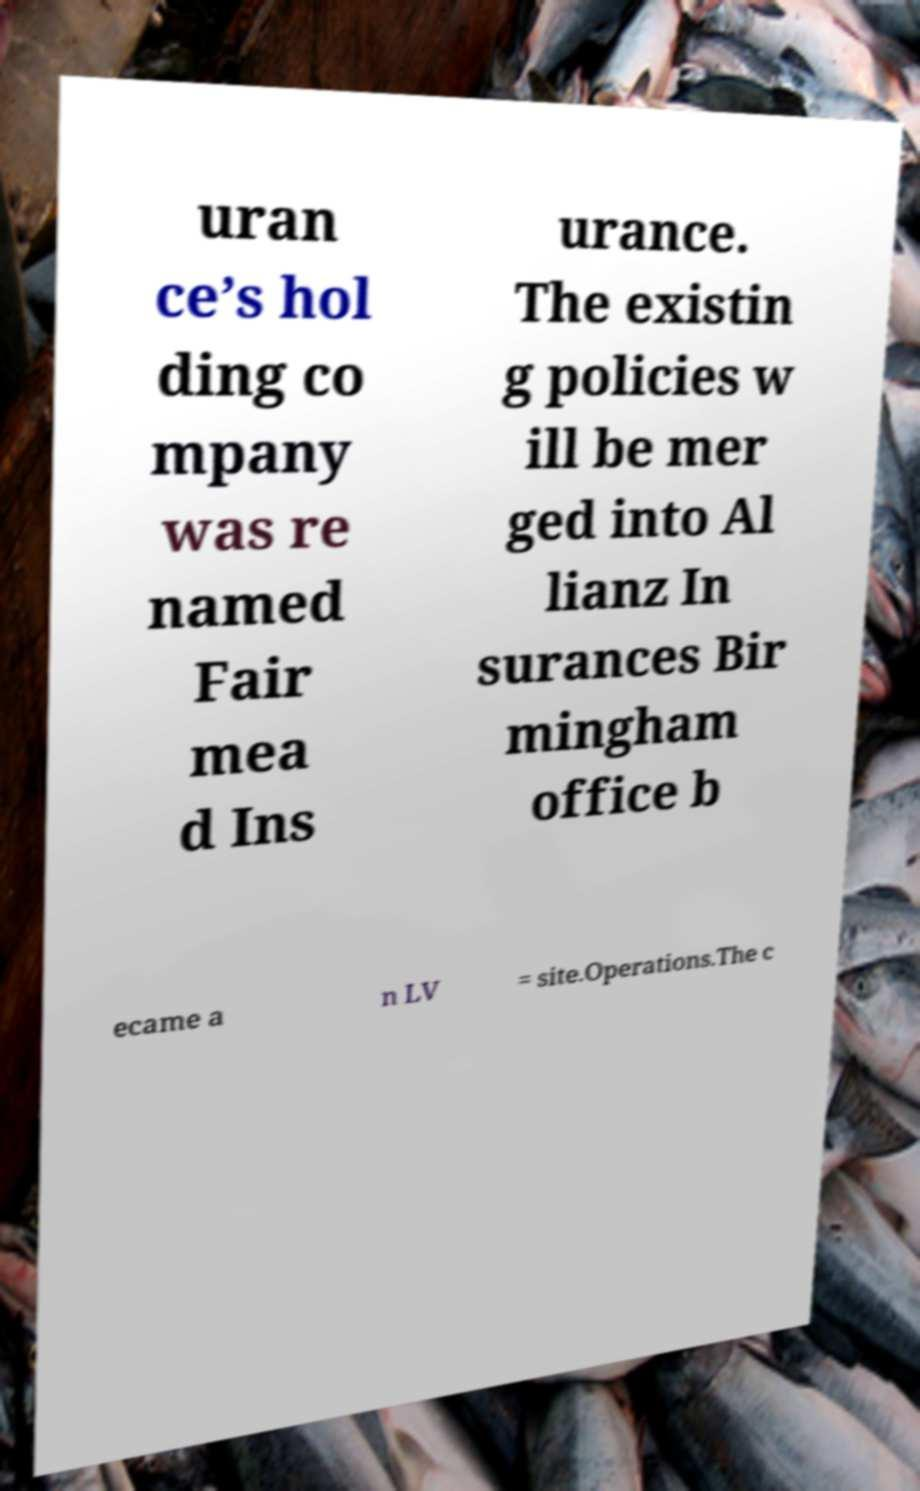For documentation purposes, I need the text within this image transcribed. Could you provide that? uran ce’s hol ding co mpany was re named Fair mea d Ins urance. The existin g policies w ill be mer ged into Al lianz In surances Bir mingham office b ecame a n LV = site.Operations.The c 